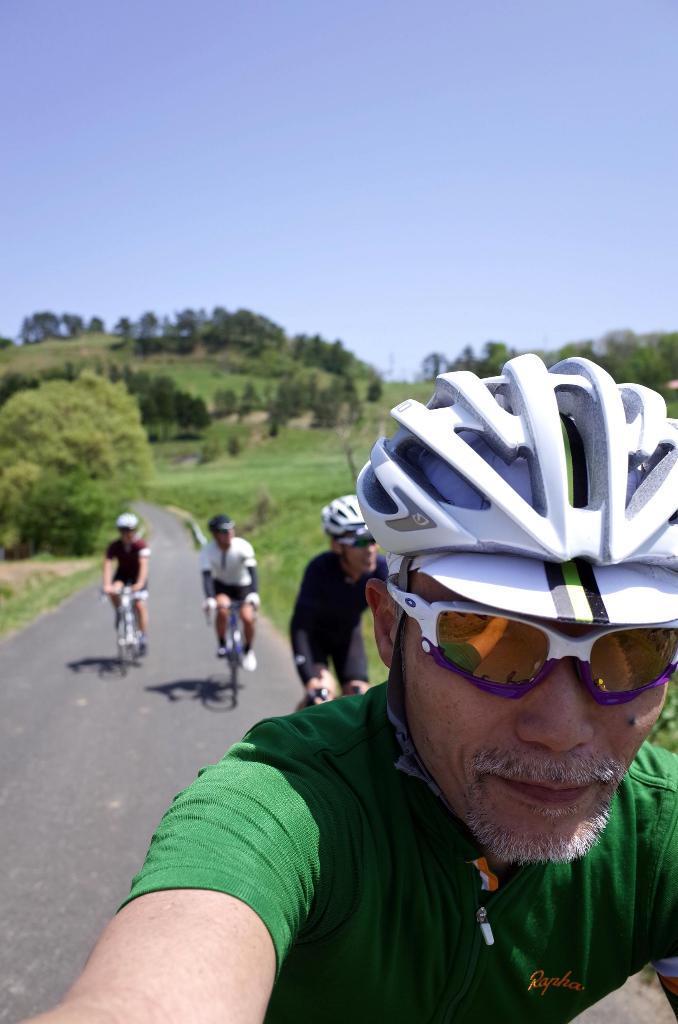Describe this image in one or two sentences. In this image there are four persons who are sitting on a cycle and they are wearing helmet and goggles. In front of the image there is one person who is wearing green shirt and on the background there is sky and in the middle of the image there are trees and grass is there. 